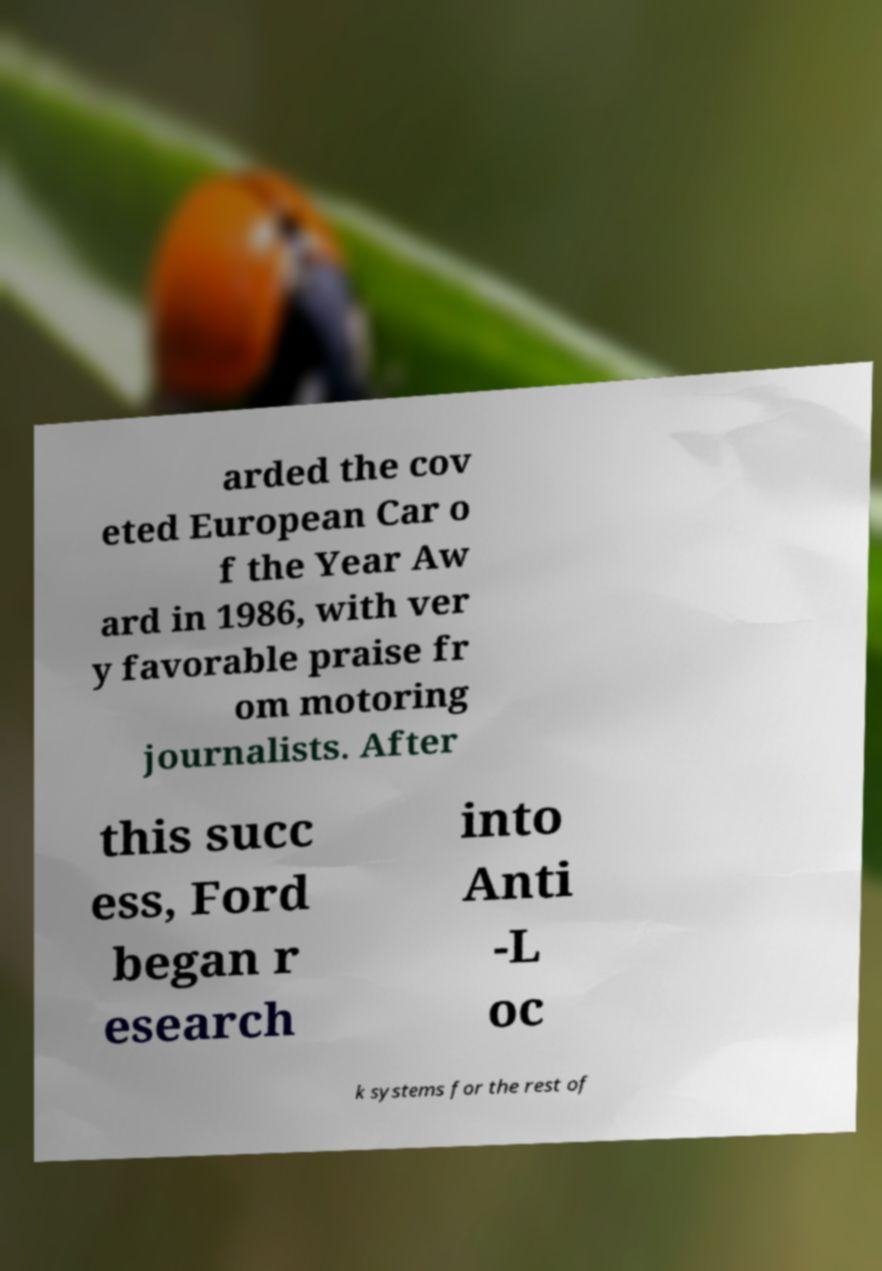What messages or text are displayed in this image? I need them in a readable, typed format. arded the cov eted European Car o f the Year Aw ard in 1986, with ver y favorable praise fr om motoring journalists. After this succ ess, Ford began r esearch into Anti -L oc k systems for the rest of 